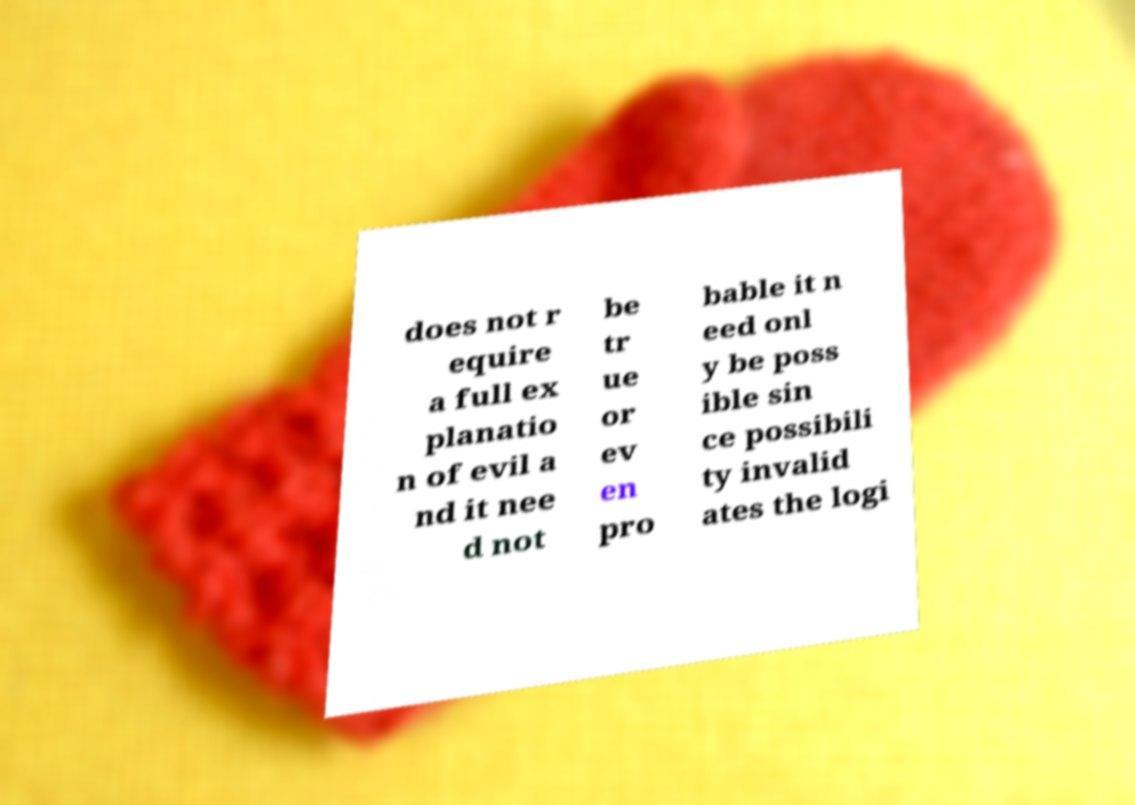I need the written content from this picture converted into text. Can you do that? does not r equire a full ex planatio n of evil a nd it nee d not be tr ue or ev en pro bable it n eed onl y be poss ible sin ce possibili ty invalid ates the logi 